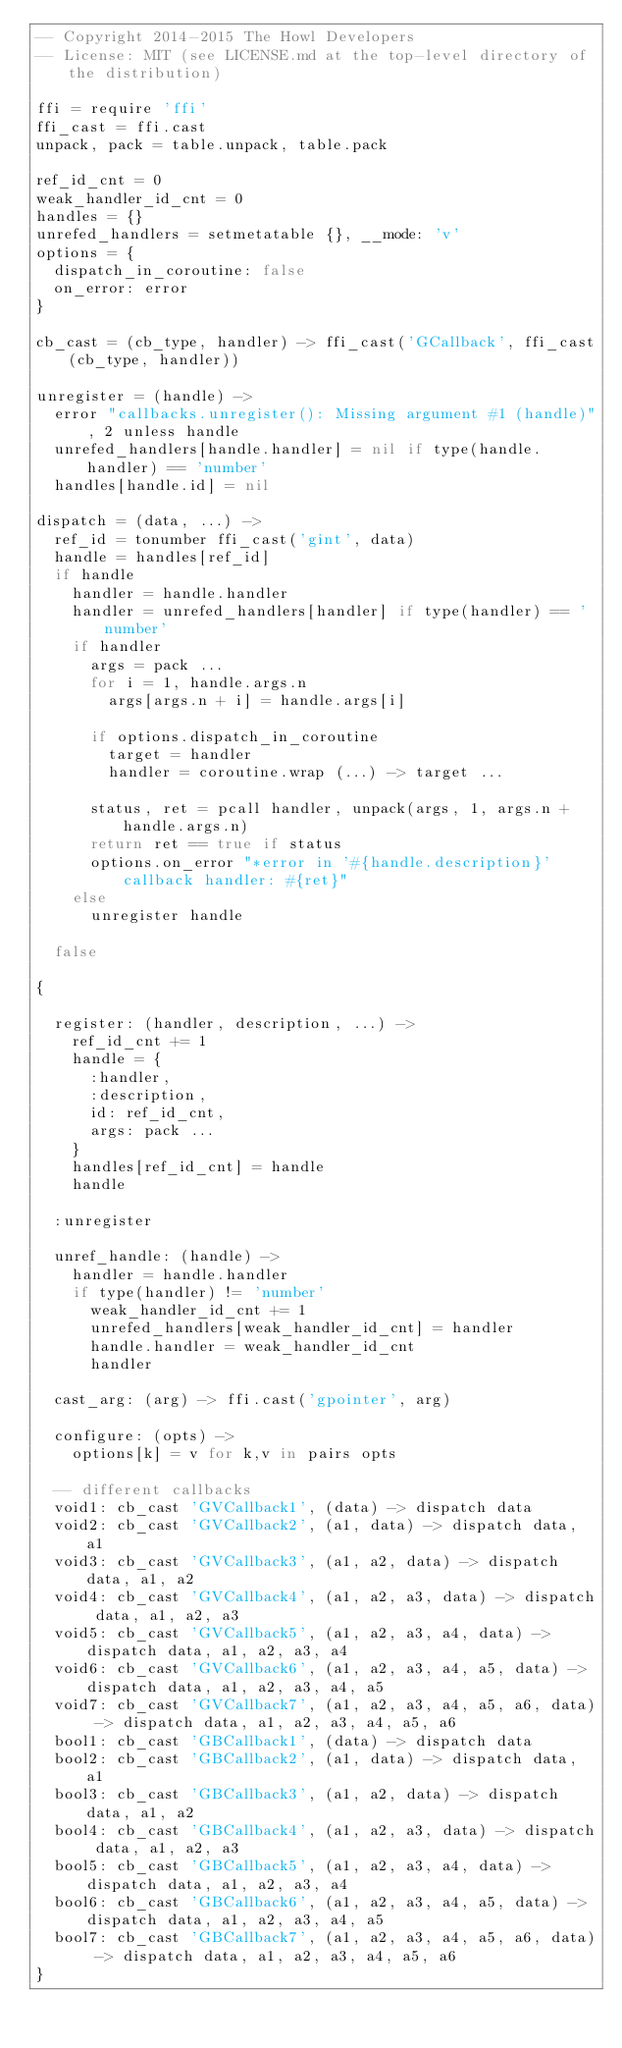Convert code to text. <code><loc_0><loc_0><loc_500><loc_500><_MoonScript_>-- Copyright 2014-2015 The Howl Developers
-- License: MIT (see LICENSE.md at the top-level directory of the distribution)

ffi = require 'ffi'
ffi_cast = ffi.cast
unpack, pack = table.unpack, table.pack

ref_id_cnt = 0
weak_handler_id_cnt = 0
handles = {}
unrefed_handlers = setmetatable {}, __mode: 'v'
options = {
  dispatch_in_coroutine: false
  on_error: error
}

cb_cast = (cb_type, handler) -> ffi_cast('GCallback', ffi_cast(cb_type, handler))

unregister = (handle) ->
  error "callbacks.unregister(): Missing argument #1 (handle)", 2 unless handle
  unrefed_handlers[handle.handler] = nil if type(handle.handler) == 'number'
  handles[handle.id] = nil

dispatch = (data, ...) ->
  ref_id = tonumber ffi_cast('gint', data)
  handle = handles[ref_id]
  if handle
    handler = handle.handler
    handler = unrefed_handlers[handler] if type(handler) == 'number'
    if handler
      args = pack ...
      for i = 1, handle.args.n
        args[args.n + i] = handle.args[i]

      if options.dispatch_in_coroutine
        target = handler
        handler = coroutine.wrap (...) -> target ...

      status, ret = pcall handler, unpack(args, 1, args.n + handle.args.n)
      return ret == true if status
      options.on_error "*error in '#{handle.description}' callback handler: #{ret}"
    else
      unregister handle

  false

{

  register: (handler, description, ...) ->
    ref_id_cnt += 1
    handle = {
      :handler,
      :description,
      id: ref_id_cnt,
      args: pack ...
    }
    handles[ref_id_cnt] = handle
    handle

  :unregister

  unref_handle: (handle) ->
    handler = handle.handler
    if type(handler) != 'number'
      weak_handler_id_cnt += 1
      unrefed_handlers[weak_handler_id_cnt] = handler
      handle.handler = weak_handler_id_cnt
      handler

  cast_arg: (arg) -> ffi.cast('gpointer', arg)

  configure: (opts) ->
    options[k] = v for k,v in pairs opts

  -- different callbacks
  void1: cb_cast 'GVCallback1', (data) -> dispatch data
  void2: cb_cast 'GVCallback2', (a1, data) -> dispatch data, a1
  void3: cb_cast 'GVCallback3', (a1, a2, data) -> dispatch data, a1, a2
  void4: cb_cast 'GVCallback4', (a1, a2, a3, data) -> dispatch data, a1, a2, a3
  void5: cb_cast 'GVCallback5', (a1, a2, a3, a4, data) -> dispatch data, a1, a2, a3, a4
  void6: cb_cast 'GVCallback6', (a1, a2, a3, a4, a5, data) -> dispatch data, a1, a2, a3, a4, a5
  void7: cb_cast 'GVCallback7', (a1, a2, a3, a4, a5, a6, data) -> dispatch data, a1, a2, a3, a4, a5, a6
  bool1: cb_cast 'GBCallback1', (data) -> dispatch data
  bool2: cb_cast 'GBCallback2', (a1, data) -> dispatch data, a1
  bool3: cb_cast 'GBCallback3', (a1, a2, data) -> dispatch data, a1, a2
  bool4: cb_cast 'GBCallback4', (a1, a2, a3, data) -> dispatch data, a1, a2, a3
  bool5: cb_cast 'GBCallback5', (a1, a2, a3, a4, data) -> dispatch data, a1, a2, a3, a4
  bool6: cb_cast 'GBCallback6', (a1, a2, a3, a4, a5, data) -> dispatch data, a1, a2, a3, a4, a5
  bool7: cb_cast 'GBCallback7', (a1, a2, a3, a4, a5, a6, data) -> dispatch data, a1, a2, a3, a4, a5, a6
}
</code> 